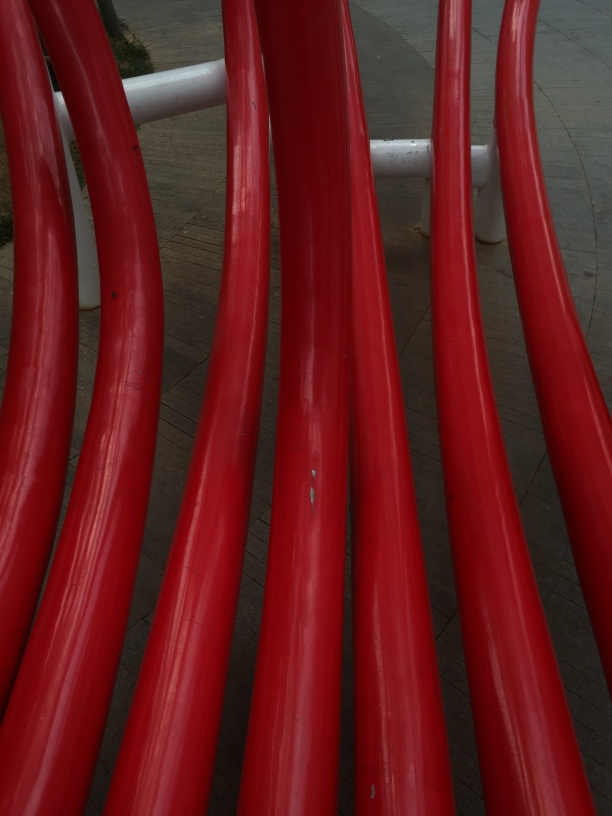How does the composition of this image influence its artistic value? The composition of the image, with its emphasis on the curves, lines, and the strong contrast between the red and its environment, creates a dynamic visual flow. The perspective used here leads the viewer's eye through the image and adds to the sense of movement and energy, which is a key element in the artistic value of the photograph. 